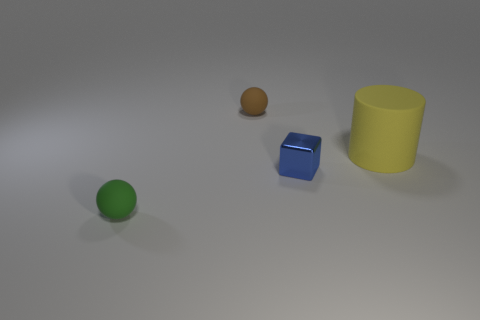Subtract all gray spheres. Subtract all green cylinders. How many spheres are left? 2 Add 1 blue metal cubes. How many objects exist? 5 Subtract all cylinders. How many objects are left? 3 Add 3 tiny matte balls. How many tiny matte balls are left? 5 Add 1 big yellow rubber objects. How many big yellow rubber objects exist? 2 Subtract 1 yellow cylinders. How many objects are left? 3 Subtract all matte things. Subtract all tiny blue metallic cubes. How many objects are left? 0 